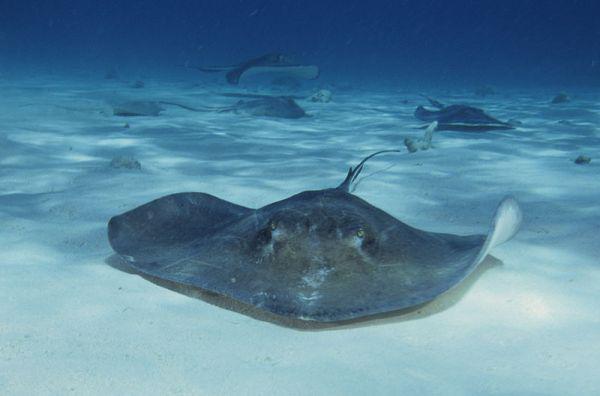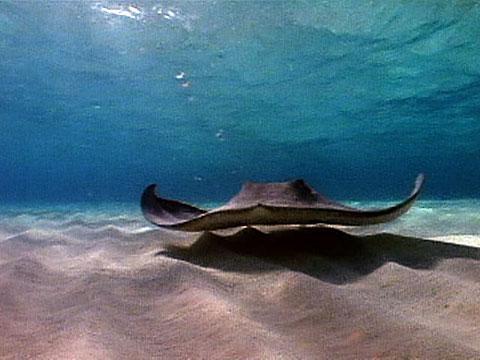The first image is the image on the left, the second image is the image on the right. Assess this claim about the two images: "The left image shows two rays moving toward the right.". Correct or not? Answer yes or no. No. 